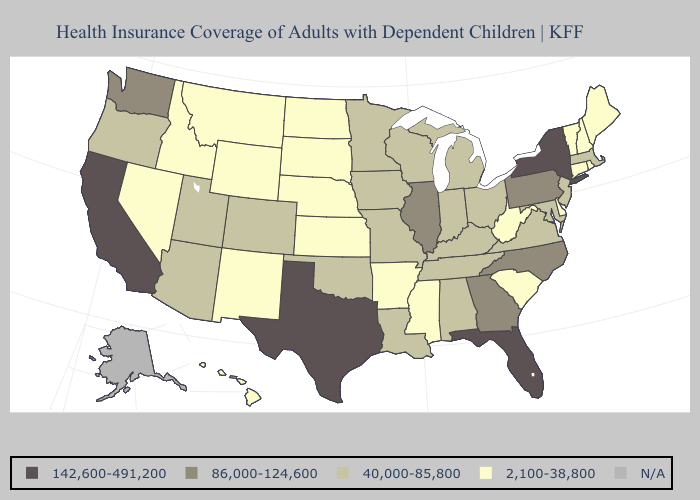Does Wyoming have the lowest value in the West?
Answer briefly. Yes. Does Iowa have the lowest value in the USA?
Short answer required. No. Does Hawaii have the highest value in the West?
Give a very brief answer. No. Does Utah have the lowest value in the West?
Keep it brief. No. What is the value of South Dakota?
Quick response, please. 2,100-38,800. Among the states that border Indiana , which have the lowest value?
Concise answer only. Kentucky, Michigan, Ohio. What is the value of New Hampshire?
Answer briefly. 2,100-38,800. What is the value of Delaware?
Give a very brief answer. 2,100-38,800. What is the lowest value in states that border Missouri?
Write a very short answer. 2,100-38,800. Does Texas have the highest value in the USA?
Concise answer only. Yes. What is the value of Oklahoma?
Short answer required. 40,000-85,800. What is the highest value in the USA?
Concise answer only. 142,600-491,200. What is the value of South Dakota?
Concise answer only. 2,100-38,800. Which states have the lowest value in the MidWest?
Write a very short answer. Kansas, Nebraska, North Dakota, South Dakota. 